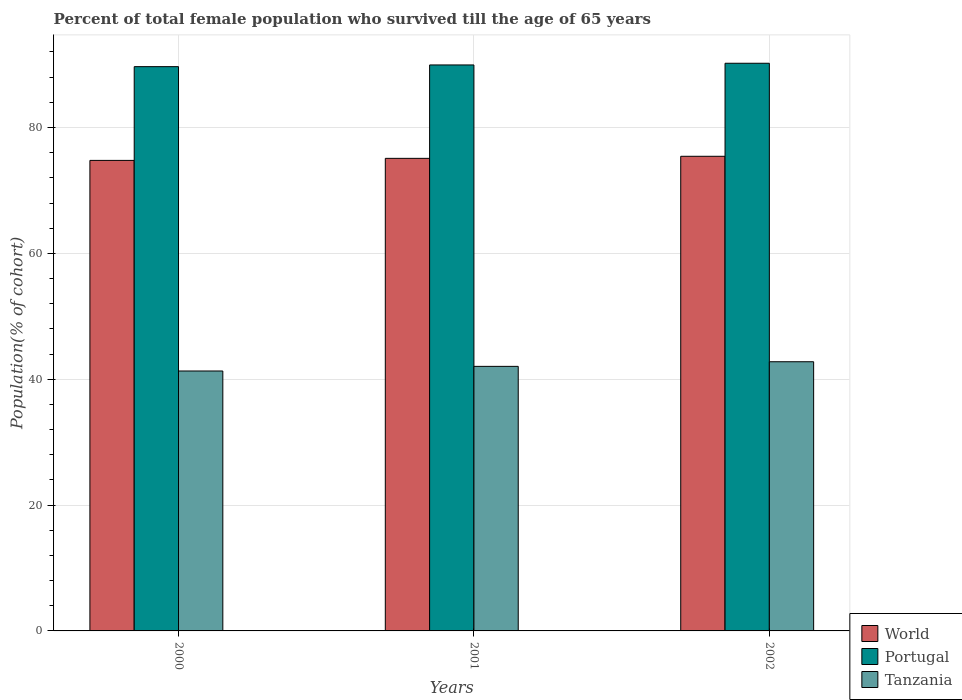Are the number of bars per tick equal to the number of legend labels?
Offer a terse response. Yes. What is the percentage of total female population who survived till the age of 65 years in Portugal in 2001?
Give a very brief answer. 89.94. Across all years, what is the maximum percentage of total female population who survived till the age of 65 years in Tanzania?
Give a very brief answer. 42.78. Across all years, what is the minimum percentage of total female population who survived till the age of 65 years in Tanzania?
Offer a very short reply. 41.31. In which year was the percentage of total female population who survived till the age of 65 years in Tanzania maximum?
Give a very brief answer. 2002. What is the total percentage of total female population who survived till the age of 65 years in Tanzania in the graph?
Your answer should be very brief. 126.12. What is the difference between the percentage of total female population who survived till the age of 65 years in Portugal in 2001 and that in 2002?
Provide a succinct answer. -0.27. What is the difference between the percentage of total female population who survived till the age of 65 years in Tanzania in 2000 and the percentage of total female population who survived till the age of 65 years in Portugal in 2001?
Ensure brevity in your answer.  -48.63. What is the average percentage of total female population who survived till the age of 65 years in Tanzania per year?
Give a very brief answer. 42.04. In the year 2000, what is the difference between the percentage of total female population who survived till the age of 65 years in Portugal and percentage of total female population who survived till the age of 65 years in World?
Provide a short and direct response. 14.9. In how many years, is the percentage of total female population who survived till the age of 65 years in Portugal greater than 48 %?
Keep it short and to the point. 3. What is the ratio of the percentage of total female population who survived till the age of 65 years in Tanzania in 2000 to that in 2001?
Your answer should be very brief. 0.98. What is the difference between the highest and the second highest percentage of total female population who survived till the age of 65 years in World?
Your response must be concise. 0.33. What is the difference between the highest and the lowest percentage of total female population who survived till the age of 65 years in Tanzania?
Your answer should be very brief. 1.47. In how many years, is the percentage of total female population who survived till the age of 65 years in World greater than the average percentage of total female population who survived till the age of 65 years in World taken over all years?
Provide a short and direct response. 1. Is the sum of the percentage of total female population who survived till the age of 65 years in Portugal in 2000 and 2001 greater than the maximum percentage of total female population who survived till the age of 65 years in World across all years?
Your answer should be compact. Yes. What does the 2nd bar from the left in 2002 represents?
Offer a very short reply. Portugal. Are all the bars in the graph horizontal?
Offer a terse response. No. How many years are there in the graph?
Make the answer very short. 3. What is the difference between two consecutive major ticks on the Y-axis?
Offer a terse response. 20. Are the values on the major ticks of Y-axis written in scientific E-notation?
Ensure brevity in your answer.  No. What is the title of the graph?
Ensure brevity in your answer.  Percent of total female population who survived till the age of 65 years. Does "France" appear as one of the legend labels in the graph?
Provide a short and direct response. No. What is the label or title of the X-axis?
Offer a very short reply. Years. What is the label or title of the Y-axis?
Offer a terse response. Population(% of cohort). What is the Population(% of cohort) in World in 2000?
Offer a terse response. 74.77. What is the Population(% of cohort) of Portugal in 2000?
Provide a succinct answer. 89.67. What is the Population(% of cohort) in Tanzania in 2000?
Your response must be concise. 41.31. What is the Population(% of cohort) of World in 2001?
Provide a short and direct response. 75.1. What is the Population(% of cohort) of Portugal in 2001?
Your answer should be very brief. 89.94. What is the Population(% of cohort) in Tanzania in 2001?
Offer a terse response. 42.04. What is the Population(% of cohort) of World in 2002?
Your response must be concise. 75.43. What is the Population(% of cohort) in Portugal in 2002?
Ensure brevity in your answer.  90.21. What is the Population(% of cohort) in Tanzania in 2002?
Your answer should be compact. 42.78. Across all years, what is the maximum Population(% of cohort) in World?
Provide a succinct answer. 75.43. Across all years, what is the maximum Population(% of cohort) in Portugal?
Offer a very short reply. 90.21. Across all years, what is the maximum Population(% of cohort) in Tanzania?
Give a very brief answer. 42.78. Across all years, what is the minimum Population(% of cohort) of World?
Provide a short and direct response. 74.77. Across all years, what is the minimum Population(% of cohort) in Portugal?
Ensure brevity in your answer.  89.67. Across all years, what is the minimum Population(% of cohort) of Tanzania?
Ensure brevity in your answer.  41.31. What is the total Population(% of cohort) of World in the graph?
Offer a terse response. 225.3. What is the total Population(% of cohort) of Portugal in the graph?
Offer a very short reply. 269.82. What is the total Population(% of cohort) in Tanzania in the graph?
Ensure brevity in your answer.  126.12. What is the difference between the Population(% of cohort) of World in 2000 and that in 2001?
Your answer should be very brief. -0.33. What is the difference between the Population(% of cohort) of Portugal in 2000 and that in 2001?
Ensure brevity in your answer.  -0.27. What is the difference between the Population(% of cohort) in Tanzania in 2000 and that in 2001?
Keep it short and to the point. -0.74. What is the difference between the Population(% of cohort) in World in 2000 and that in 2002?
Offer a terse response. -0.65. What is the difference between the Population(% of cohort) of Portugal in 2000 and that in 2002?
Offer a very short reply. -0.54. What is the difference between the Population(% of cohort) of Tanzania in 2000 and that in 2002?
Offer a very short reply. -1.47. What is the difference between the Population(% of cohort) of World in 2001 and that in 2002?
Provide a short and direct response. -0.33. What is the difference between the Population(% of cohort) in Portugal in 2001 and that in 2002?
Offer a terse response. -0.27. What is the difference between the Population(% of cohort) of Tanzania in 2001 and that in 2002?
Your answer should be compact. -0.74. What is the difference between the Population(% of cohort) of World in 2000 and the Population(% of cohort) of Portugal in 2001?
Your answer should be very brief. -15.17. What is the difference between the Population(% of cohort) of World in 2000 and the Population(% of cohort) of Tanzania in 2001?
Your response must be concise. 32.73. What is the difference between the Population(% of cohort) of Portugal in 2000 and the Population(% of cohort) of Tanzania in 2001?
Offer a terse response. 47.63. What is the difference between the Population(% of cohort) of World in 2000 and the Population(% of cohort) of Portugal in 2002?
Give a very brief answer. -15.44. What is the difference between the Population(% of cohort) of World in 2000 and the Population(% of cohort) of Tanzania in 2002?
Provide a succinct answer. 32. What is the difference between the Population(% of cohort) of Portugal in 2000 and the Population(% of cohort) of Tanzania in 2002?
Your answer should be very brief. 46.89. What is the difference between the Population(% of cohort) in World in 2001 and the Population(% of cohort) in Portugal in 2002?
Provide a short and direct response. -15.11. What is the difference between the Population(% of cohort) of World in 2001 and the Population(% of cohort) of Tanzania in 2002?
Give a very brief answer. 32.32. What is the difference between the Population(% of cohort) in Portugal in 2001 and the Population(% of cohort) in Tanzania in 2002?
Offer a very short reply. 47.16. What is the average Population(% of cohort) in World per year?
Provide a succinct answer. 75.1. What is the average Population(% of cohort) in Portugal per year?
Your answer should be compact. 89.94. What is the average Population(% of cohort) of Tanzania per year?
Give a very brief answer. 42.04. In the year 2000, what is the difference between the Population(% of cohort) in World and Population(% of cohort) in Portugal?
Your answer should be very brief. -14.9. In the year 2000, what is the difference between the Population(% of cohort) in World and Population(% of cohort) in Tanzania?
Offer a very short reply. 33.47. In the year 2000, what is the difference between the Population(% of cohort) of Portugal and Population(% of cohort) of Tanzania?
Your answer should be compact. 48.36. In the year 2001, what is the difference between the Population(% of cohort) of World and Population(% of cohort) of Portugal?
Give a very brief answer. -14.84. In the year 2001, what is the difference between the Population(% of cohort) in World and Population(% of cohort) in Tanzania?
Offer a very short reply. 33.06. In the year 2001, what is the difference between the Population(% of cohort) of Portugal and Population(% of cohort) of Tanzania?
Give a very brief answer. 47.9. In the year 2002, what is the difference between the Population(% of cohort) in World and Population(% of cohort) in Portugal?
Keep it short and to the point. -14.78. In the year 2002, what is the difference between the Population(% of cohort) of World and Population(% of cohort) of Tanzania?
Make the answer very short. 32.65. In the year 2002, what is the difference between the Population(% of cohort) of Portugal and Population(% of cohort) of Tanzania?
Offer a very short reply. 47.43. What is the ratio of the Population(% of cohort) in World in 2000 to that in 2001?
Ensure brevity in your answer.  1. What is the ratio of the Population(% of cohort) of Tanzania in 2000 to that in 2001?
Make the answer very short. 0.98. What is the ratio of the Population(% of cohort) of Tanzania in 2000 to that in 2002?
Keep it short and to the point. 0.97. What is the ratio of the Population(% of cohort) in World in 2001 to that in 2002?
Offer a terse response. 1. What is the ratio of the Population(% of cohort) of Tanzania in 2001 to that in 2002?
Your answer should be very brief. 0.98. What is the difference between the highest and the second highest Population(% of cohort) of World?
Keep it short and to the point. 0.33. What is the difference between the highest and the second highest Population(% of cohort) of Portugal?
Offer a terse response. 0.27. What is the difference between the highest and the second highest Population(% of cohort) of Tanzania?
Provide a short and direct response. 0.74. What is the difference between the highest and the lowest Population(% of cohort) in World?
Offer a very short reply. 0.65. What is the difference between the highest and the lowest Population(% of cohort) in Portugal?
Give a very brief answer. 0.54. What is the difference between the highest and the lowest Population(% of cohort) of Tanzania?
Your answer should be very brief. 1.47. 